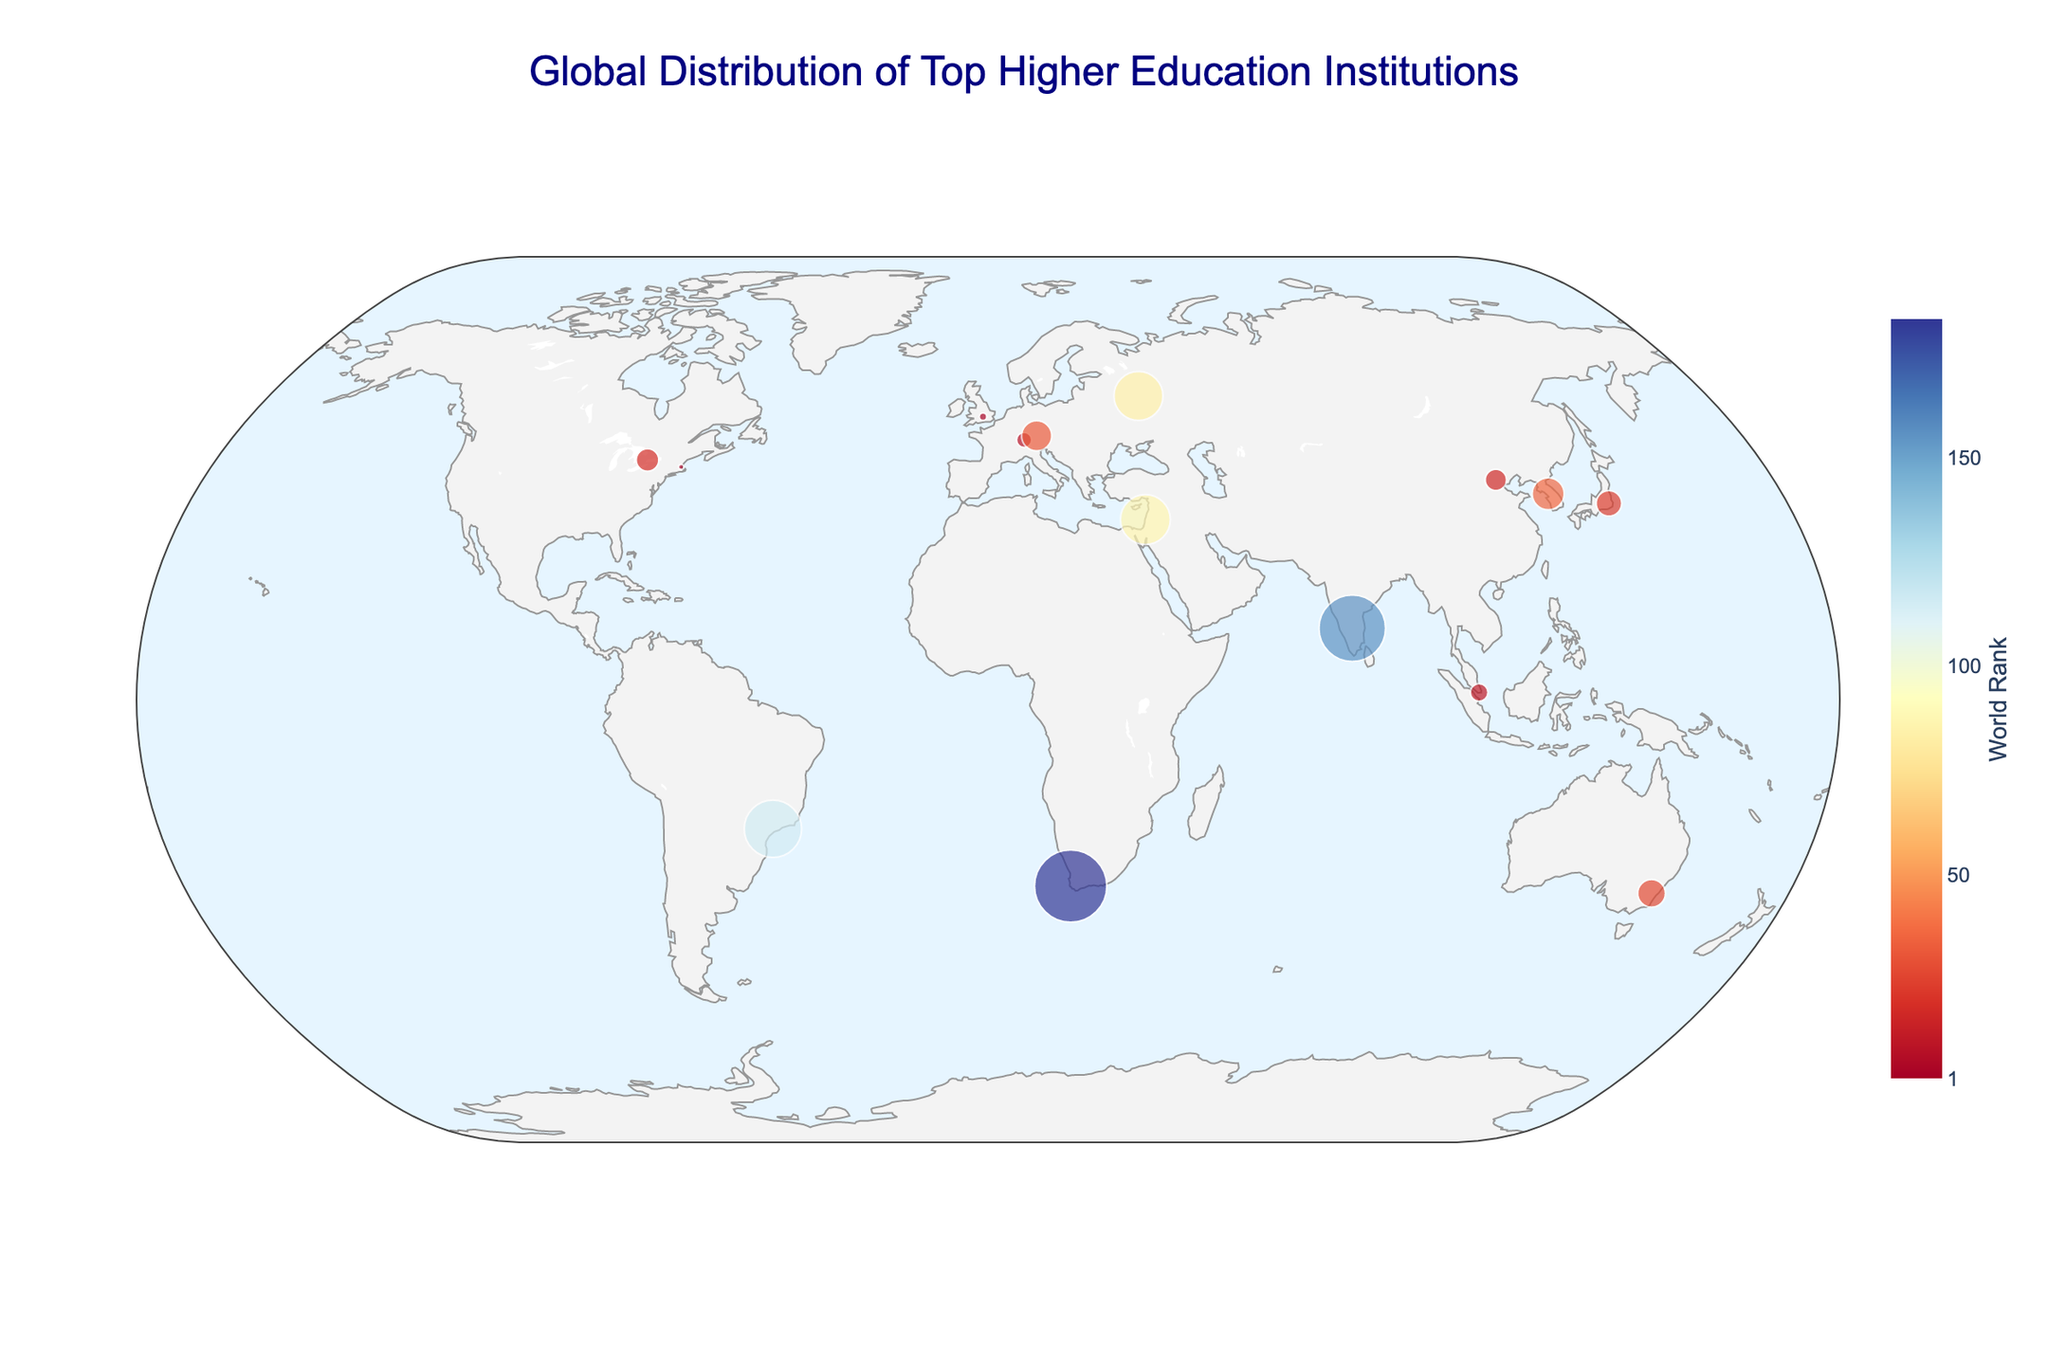Which institution is ranked number 1 in the world? By examining the color coding and the size of the points on the map, the institution with the smallest value (best rank) is Harvard University, located in the USA.
Answer: Harvard University What are the latitude and longitude coordinates of the University of Cape Town? Use the map to identify the location markers; hover over the marker representing the University of Cape Town to see its details, including latitude and longitude.
Answer: -33.9579, 18.4611 Which institution in Asia is ranked highest? Analyze the markers located in Asia and check their rankings by hovering over them; the National University of Singapore has the highest rank among the Asian institutions.
Answer: National University of Singapore Which country houses the most diverse range of specializations? Assess the number of institutions and their specializations within each country; the USA, represented only by Harvard, covers a multidisciplinary specialization. However, for more diversity in institutional specialization and multiple entries, look at countries like Japan and South Korea. We see single specializations but unique per country; thus, Australia (Environmental Studies), South Africa (African Studies), Brazil (Tropical Agriculture), and Russia (Mathematics) offer specialized concentrations.
Answer: Each listed country contributes uniquely How many higher education institutions from the Southern Hemisphere are featured in the plot? Find South Hemisphere locations on the map and count the markers; they include the Australian National University, University of Cape Town, and University of São Paulo.
Answer: 3 Which institution has a specialization in Biomedical Engineering, and where is it located? Hover over the markers to note each specialization, or use the annotation texts to find the institution specialized in Biomedical Engineering; it is the Technion - Israel Institute of Technology located in Israel.
Answer: Technion - Israel Institute of Technology, Israel Is there any country from South America represented in the plot? If so, which institution? Check the geographic plot for locations in South America; the University of São Paulo in Brazil is represented.
Answer: University of São Paulo Compare the rankings of the institutions in Germany and Japan. Which one ranks higher? Identify the markers for Germany and Japan and observe their respective ranks by hovering over them; the University of Tokyo in Japan is ranked 23, while the Ludwig Maximilian University of Munich in Germany is ranked 32. Therefore, the University of Tokyo ranks higher.
Answer: University of Tokyo Which institution has the northernmost latitude, and what is its specialization? Locate the markers at the northern extremes of the map and check their coordinates; the northernmost institution is Lomonosov Moscow State University, specializing in Mathematics.
Answer: Lomonosov Moscow State University, Mathematics 